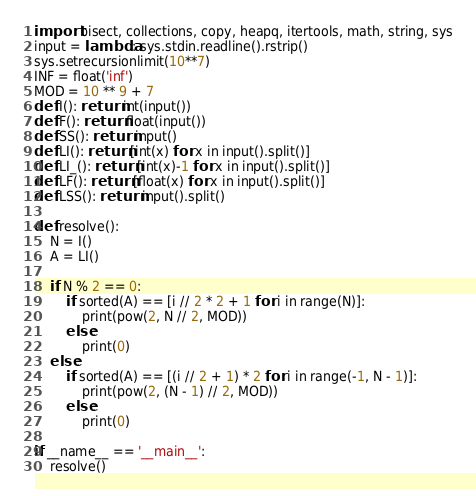Convert code to text. <code><loc_0><loc_0><loc_500><loc_500><_Python_>import bisect, collections, copy, heapq, itertools, math, string, sys
input = lambda: sys.stdin.readline().rstrip() 
sys.setrecursionlimit(10**7)
INF = float('inf')
MOD = 10 ** 9 + 7
def I(): return int(input())
def F(): return float(input())
def SS(): return input()
def LI(): return [int(x) for x in input().split()]
def LI_(): return [int(x)-1 for x in input().split()]
def LF(): return [float(x) for x in input().split()]
def LSS(): return input().split()

def resolve():
    N = I()
    A = LI()

    if N % 2 == 0:
        if sorted(A) == [i // 2 * 2 + 1 for i in range(N)]:
            print(pow(2, N // 2, MOD))
        else:
            print(0)
    else:
        if sorted(A) == [(i // 2 + 1) * 2 for i in range(-1, N - 1)]:
            print(pow(2, (N - 1) // 2, MOD))
        else:
            print(0)

if __name__ == '__main__':
    resolve()
</code> 